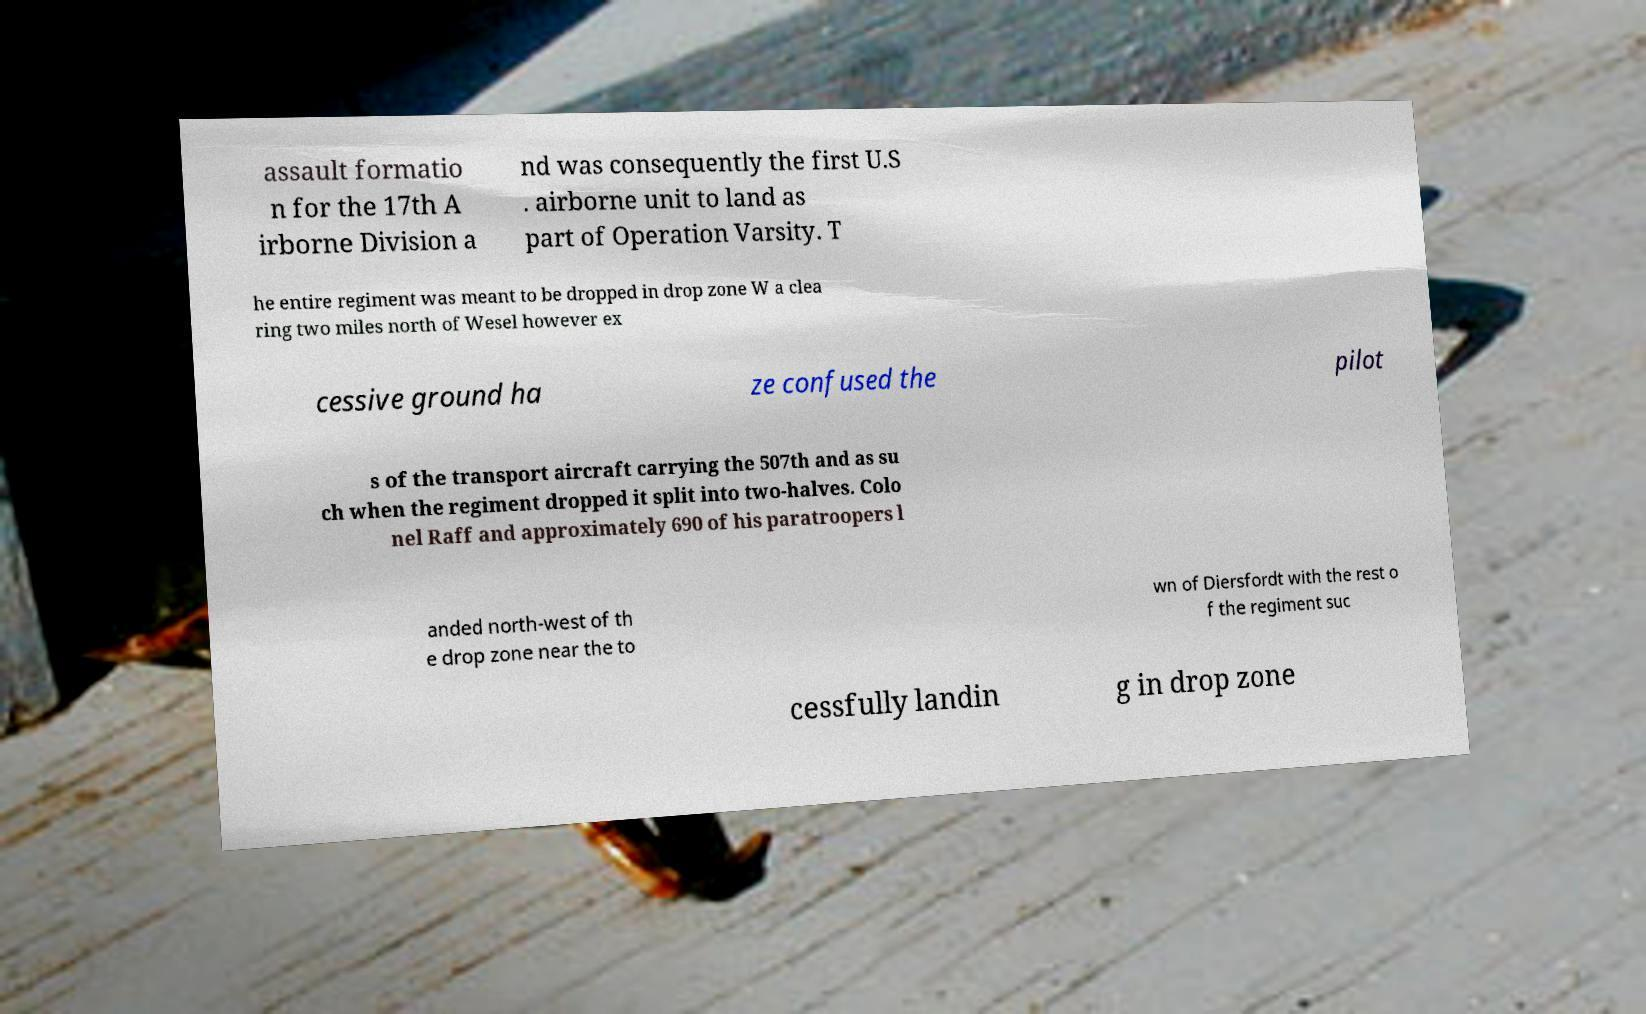Could you extract and type out the text from this image? assault formatio n for the 17th A irborne Division a nd was consequently the first U.S . airborne unit to land as part of Operation Varsity. T he entire regiment was meant to be dropped in drop zone W a clea ring two miles north of Wesel however ex cessive ground ha ze confused the pilot s of the transport aircraft carrying the 507th and as su ch when the regiment dropped it split into two-halves. Colo nel Raff and approximately 690 of his paratroopers l anded north-west of th e drop zone near the to wn of Diersfordt with the rest o f the regiment suc cessfully landin g in drop zone 